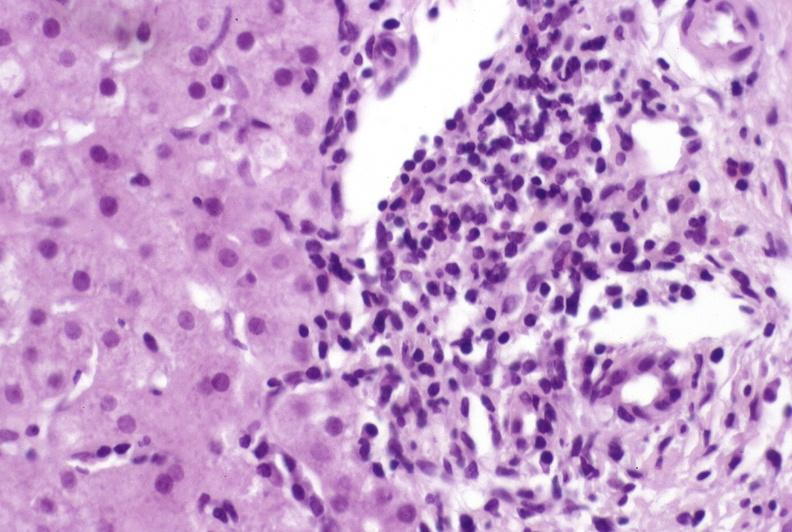does this image show primary biliary cirrhosis?
Answer the question using a single word or phrase. Yes 